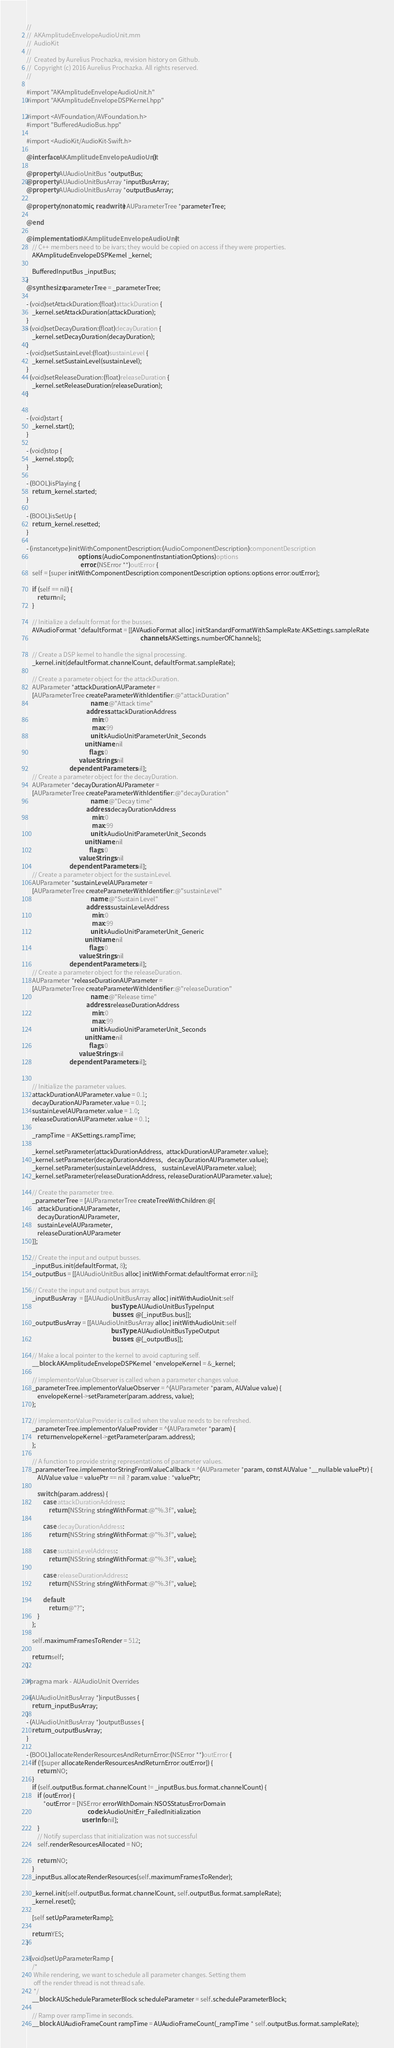Convert code to text. <code><loc_0><loc_0><loc_500><loc_500><_ObjectiveC_>//
//  AKAmplitudeEnvelopeAudioUnit.mm
//  AudioKit
//
//  Created by Aurelius Prochazka, revision history on Github.
//  Copyright (c) 2016 Aurelius Prochazka. All rights reserved.
//

#import "AKAmplitudeEnvelopeAudioUnit.h"
#import "AKAmplitudeEnvelopeDSPKernel.hpp"

#import <AVFoundation/AVFoundation.h>
#import "BufferedAudioBus.hpp"

#import <AudioKit/AudioKit-Swift.h>

@interface AKAmplitudeEnvelopeAudioUnit()

@property AUAudioUnitBus *outputBus;
@property AUAudioUnitBusArray *inputBusArray;
@property AUAudioUnitBusArray *outputBusArray;

@property (nonatomic, readwrite) AUParameterTree *parameterTree;

@end

@implementation AKAmplitudeEnvelopeAudioUnit {
    // C++ members need to be ivars; they would be copied on access if they were properties.
    AKAmplitudeEnvelopeDSPKernel _kernel;

    BufferedInputBus _inputBus;
}
@synthesize parameterTree = _parameterTree;

- (void)setAttackDuration:(float)attackDuration {
    _kernel.setAttackDuration(attackDuration);
}
- (void)setDecayDuration:(float)decayDuration {
    _kernel.setDecayDuration(decayDuration);
}
- (void)setSustainLevel:(float)sustainLevel {
    _kernel.setSustainLevel(sustainLevel);
}
- (void)setReleaseDuration:(float)releaseDuration {
    _kernel.setReleaseDuration(releaseDuration);
}


- (void)start {
    _kernel.start();
}

- (void)stop {
    _kernel.stop();
}

- (BOOL)isPlaying {
    return _kernel.started;
}

- (BOOL)isSetUp {
    return _kernel.resetted;
}

- (instancetype)initWithComponentDescription:(AudioComponentDescription)componentDescription
                                     options:(AudioComponentInstantiationOptions)options
                                       error:(NSError **)outError {
    self = [super initWithComponentDescription:componentDescription options:options error:outError];

    if (self == nil) {
        return nil;
    }

    // Initialize a default format for the busses.
    AVAudioFormat *defaultFormat = [[AVAudioFormat alloc] initStandardFormatWithSampleRate:AKSettings.sampleRate
                                                                                  channels:AKSettings.numberOfChannels];

    // Create a DSP kernel to handle the signal processing.
    _kernel.init(defaultFormat.channelCount, defaultFormat.sampleRate);

    // Create a parameter object for the attackDuration.
    AUParameter *attackDurationAUParameter =
    [AUParameterTree createParameterWithIdentifier:@"attackDuration"
                                              name:@"Attack time"
                                           address:attackDurationAddress
                                               min:0
                                               max:99
                                              unit:kAudioUnitParameterUnit_Seconds
                                          unitName:nil
                                             flags:0
                                      valueStrings:nil
                               dependentParameters:nil];
    // Create a parameter object for the decayDuration.
    AUParameter *decayDurationAUParameter =
    [AUParameterTree createParameterWithIdentifier:@"decayDuration"
                                              name:@"Decay time"
                                           address:decayDurationAddress
                                               min:0
                                               max:99
                                              unit:kAudioUnitParameterUnit_Seconds
                                          unitName:nil
                                             flags:0
                                      valueStrings:nil
                               dependentParameters:nil];
    // Create a parameter object for the sustainLevel.
    AUParameter *sustainLevelAUParameter =
    [AUParameterTree createParameterWithIdentifier:@"sustainLevel"
                                              name:@"Sustain Level"
                                           address:sustainLevelAddress
                                               min:0
                                               max:99
                                              unit:kAudioUnitParameterUnit_Generic
                                          unitName:nil
                                             flags:0
                                      valueStrings:nil
                               dependentParameters:nil];
    // Create a parameter object for the releaseDuration.
    AUParameter *releaseDurationAUParameter =
    [AUParameterTree createParameterWithIdentifier:@"releaseDuration"
                                              name:@"Release time"
                                           address:releaseDurationAddress
                                               min:0
                                               max:99
                                              unit:kAudioUnitParameterUnit_Seconds
                                          unitName:nil
                                             flags:0
                                      valueStrings:nil
                               dependentParameters:nil];


    // Initialize the parameter values.
    attackDurationAUParameter.value = 0.1;
    decayDurationAUParameter.value = 0.1;
    sustainLevelAUParameter.value = 1.0;
    releaseDurationAUParameter.value = 0.1;

    _rampTime = AKSettings.rampTime;

    _kernel.setParameter(attackDurationAddress,  attackDurationAUParameter.value);
    _kernel.setParameter(decayDurationAddress,   decayDurationAUParameter.value);
    _kernel.setParameter(sustainLevelAddress,    sustainLevelAUParameter.value);
    _kernel.setParameter(releaseDurationAddress, releaseDurationAUParameter.value);

    // Create the parameter tree.
    _parameterTree = [AUParameterTree createTreeWithChildren:@[
        attackDurationAUParameter,
        decayDurationAUParameter,
        sustainLevelAUParameter,
        releaseDurationAUParameter
    ]];

    // Create the input and output busses.
    _inputBus.init(defaultFormat, 8);
    _outputBus = [[AUAudioUnitBus alloc] initWithFormat:defaultFormat error:nil];

    // Create the input and output bus arrays.
    _inputBusArray  = [[AUAudioUnitBusArray alloc] initWithAudioUnit:self
                                                             busType:AUAudioUnitBusTypeInput
                                                              busses: @[_inputBus.bus]];
    _outputBusArray = [[AUAudioUnitBusArray alloc] initWithAudioUnit:self
                                                             busType:AUAudioUnitBusTypeOutput
                                                              busses: @[_outputBus]];

    // Make a local pointer to the kernel to avoid capturing self.
    __block AKAmplitudeEnvelopeDSPKernel *envelopeKernel = &_kernel;

    // implementorValueObserver is called when a parameter changes value.
    _parameterTree.implementorValueObserver = ^(AUParameter *param, AUValue value) {
        envelopeKernel->setParameter(param.address, value);
    };

    // implementorValueProvider is called when the value needs to be refreshed.
    _parameterTree.implementorValueProvider = ^(AUParameter *param) {
        return envelopeKernel->getParameter(param.address);
    };

    // A function to provide string representations of parameter values.
    _parameterTree.implementorStringFromValueCallback = ^(AUParameter *param, const AUValue *__nullable valuePtr) {
        AUValue value = valuePtr == nil ? param.value : *valuePtr;

        switch (param.address) {
            case attackDurationAddress:
                return [NSString stringWithFormat:@"%.3f", value];

            case decayDurationAddress:
                return [NSString stringWithFormat:@"%.3f", value];

            case sustainLevelAddress:
                return [NSString stringWithFormat:@"%.3f", value];

            case releaseDurationAddress:
                return [NSString stringWithFormat:@"%.3f", value];

            default:
                return @"?";
        }
    };

    self.maximumFramesToRender = 512;

    return self;
}

#pragma mark - AUAudioUnit Overrides

- (AUAudioUnitBusArray *)inputBusses {
    return _inputBusArray;
}
- (AUAudioUnitBusArray *)outputBusses {
    return _outputBusArray;
}

- (BOOL)allocateRenderResourcesAndReturnError:(NSError **)outError {
    if (![super allocateRenderResourcesAndReturnError:outError]) {
        return NO;
    }
    if (self.outputBus.format.channelCount != _inputBus.bus.format.channelCount) {
        if (outError) {
            *outError = [NSError errorWithDomain:NSOSStatusErrorDomain
                                            code:kAudioUnitErr_FailedInitialization
                                        userInfo:nil];
        }
        // Notify superclass that initialization was not successful
        self.renderResourcesAllocated = NO;

        return NO;
    }
    _inputBus.allocateRenderResources(self.maximumFramesToRender);

    _kernel.init(self.outputBus.format.channelCount, self.outputBus.format.sampleRate);
    _kernel.reset();

    [self setUpParameterRamp];

    return YES;
}

- (void)setUpParameterRamp {
    /*
     While rendering, we want to schedule all parameter changes. Setting them
     off the render thread is not thread safe.
     */
    __block AUScheduleParameterBlock scheduleParameter = self.scheduleParameterBlock;

    // Ramp over rampTime in seconds.
    __block AUAudioFrameCount rampTime = AUAudioFrameCount(_rampTime * self.outputBus.format.sampleRate);
</code> 